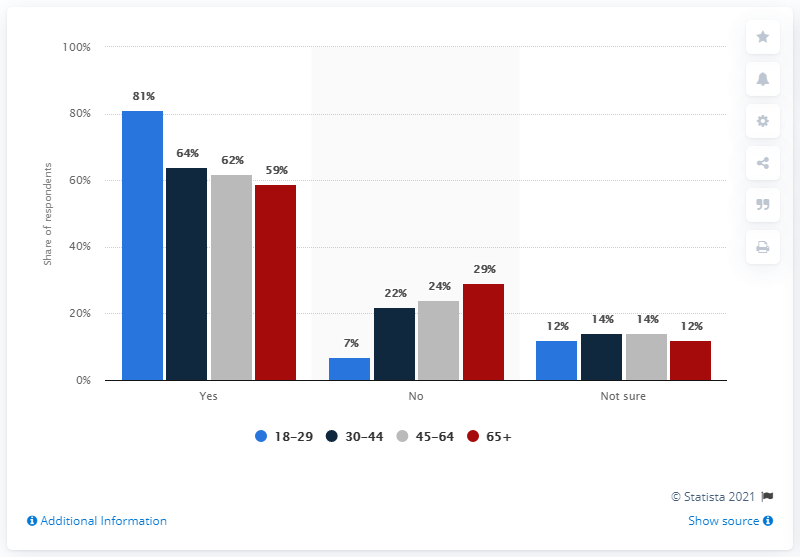How many bars in the chart below 40 %?
 8 